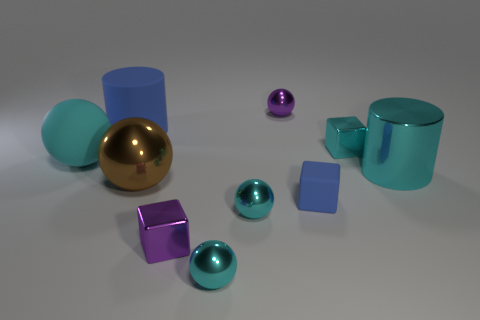How many cyan balls must be subtracted to get 1 cyan balls? 2 Subtract all tiny rubber blocks. How many blocks are left? 2 Subtract all cyan cylinders. How many cylinders are left? 1 Subtract all cubes. How many objects are left? 7 Subtract all purple blocks. How many cyan balls are left? 3 Subtract 1 cylinders. How many cylinders are left? 1 Subtract all gray cylinders. Subtract all purple cubes. How many cylinders are left? 2 Subtract all large blue matte objects. Subtract all big blue matte things. How many objects are left? 8 Add 3 purple cubes. How many purple cubes are left? 4 Add 4 tiny things. How many tiny things exist? 10 